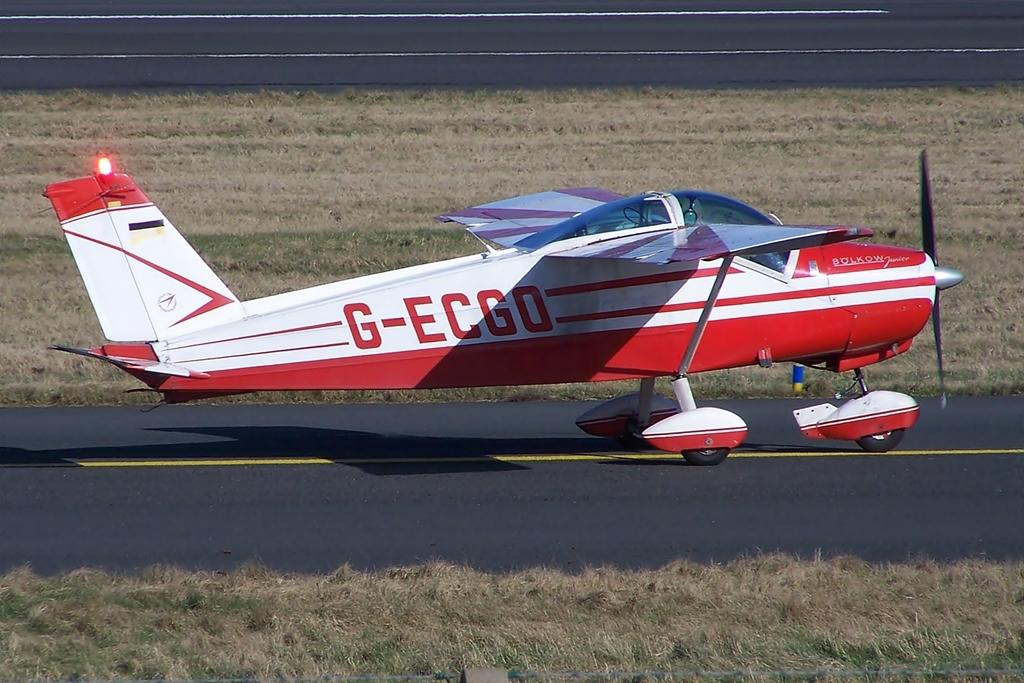<image>
Share a concise interpretation of the image provided. A Bolkow Junior propellor plane with the marking G-ECGO on it's side. 